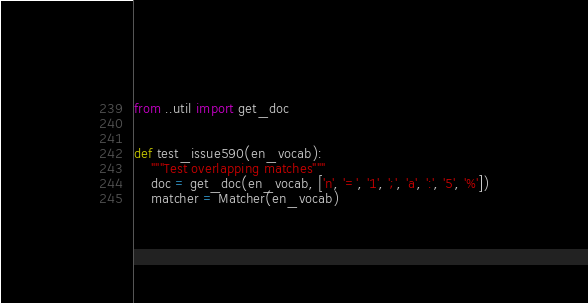Convert code to text. <code><loc_0><loc_0><loc_500><loc_500><_Python_>from ..util import get_doc


def test_issue590(en_vocab):
    """Test overlapping matches"""
    doc = get_doc(en_vocab, ['n', '=', '1', ';', 'a', ':', '5', '%'])
    matcher = Matcher(en_vocab)</code> 